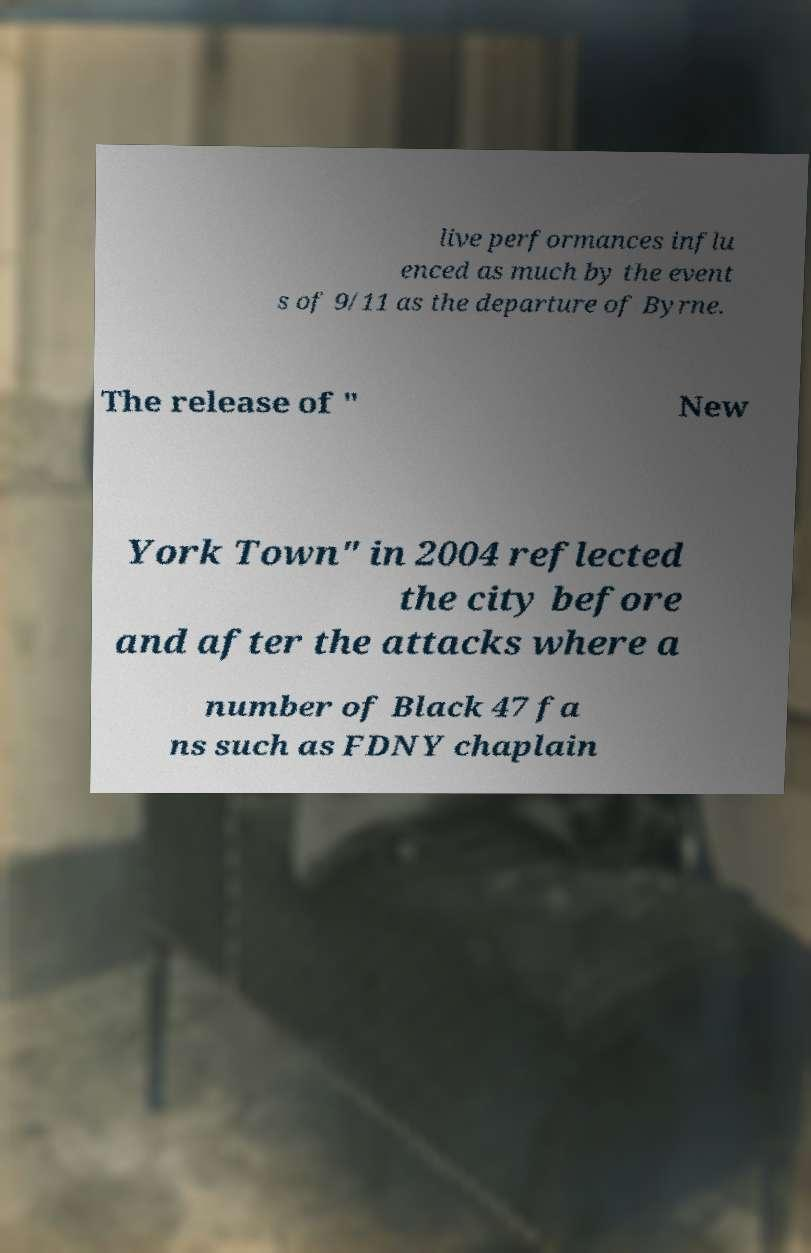Can you accurately transcribe the text from the provided image for me? live performances influ enced as much by the event s of 9/11 as the departure of Byrne. The release of " New York Town" in 2004 reflected the city before and after the attacks where a number of Black 47 fa ns such as FDNY chaplain 